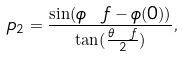<formula> <loc_0><loc_0><loc_500><loc_500>\ p _ { 2 } = \frac { \sin ( \phi \ f - \phi ( 0 ) ) } { \tan ( \frac { \theta \ f } { 2 } ) } ,</formula> 